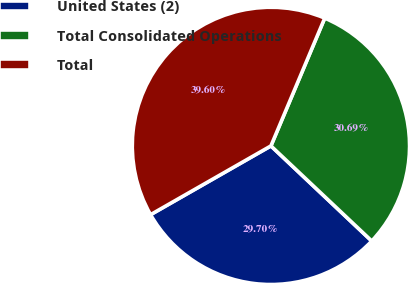<chart> <loc_0><loc_0><loc_500><loc_500><pie_chart><fcel>United States (2)<fcel>Total Consolidated Operations<fcel>Total<nl><fcel>29.7%<fcel>30.69%<fcel>39.6%<nl></chart> 